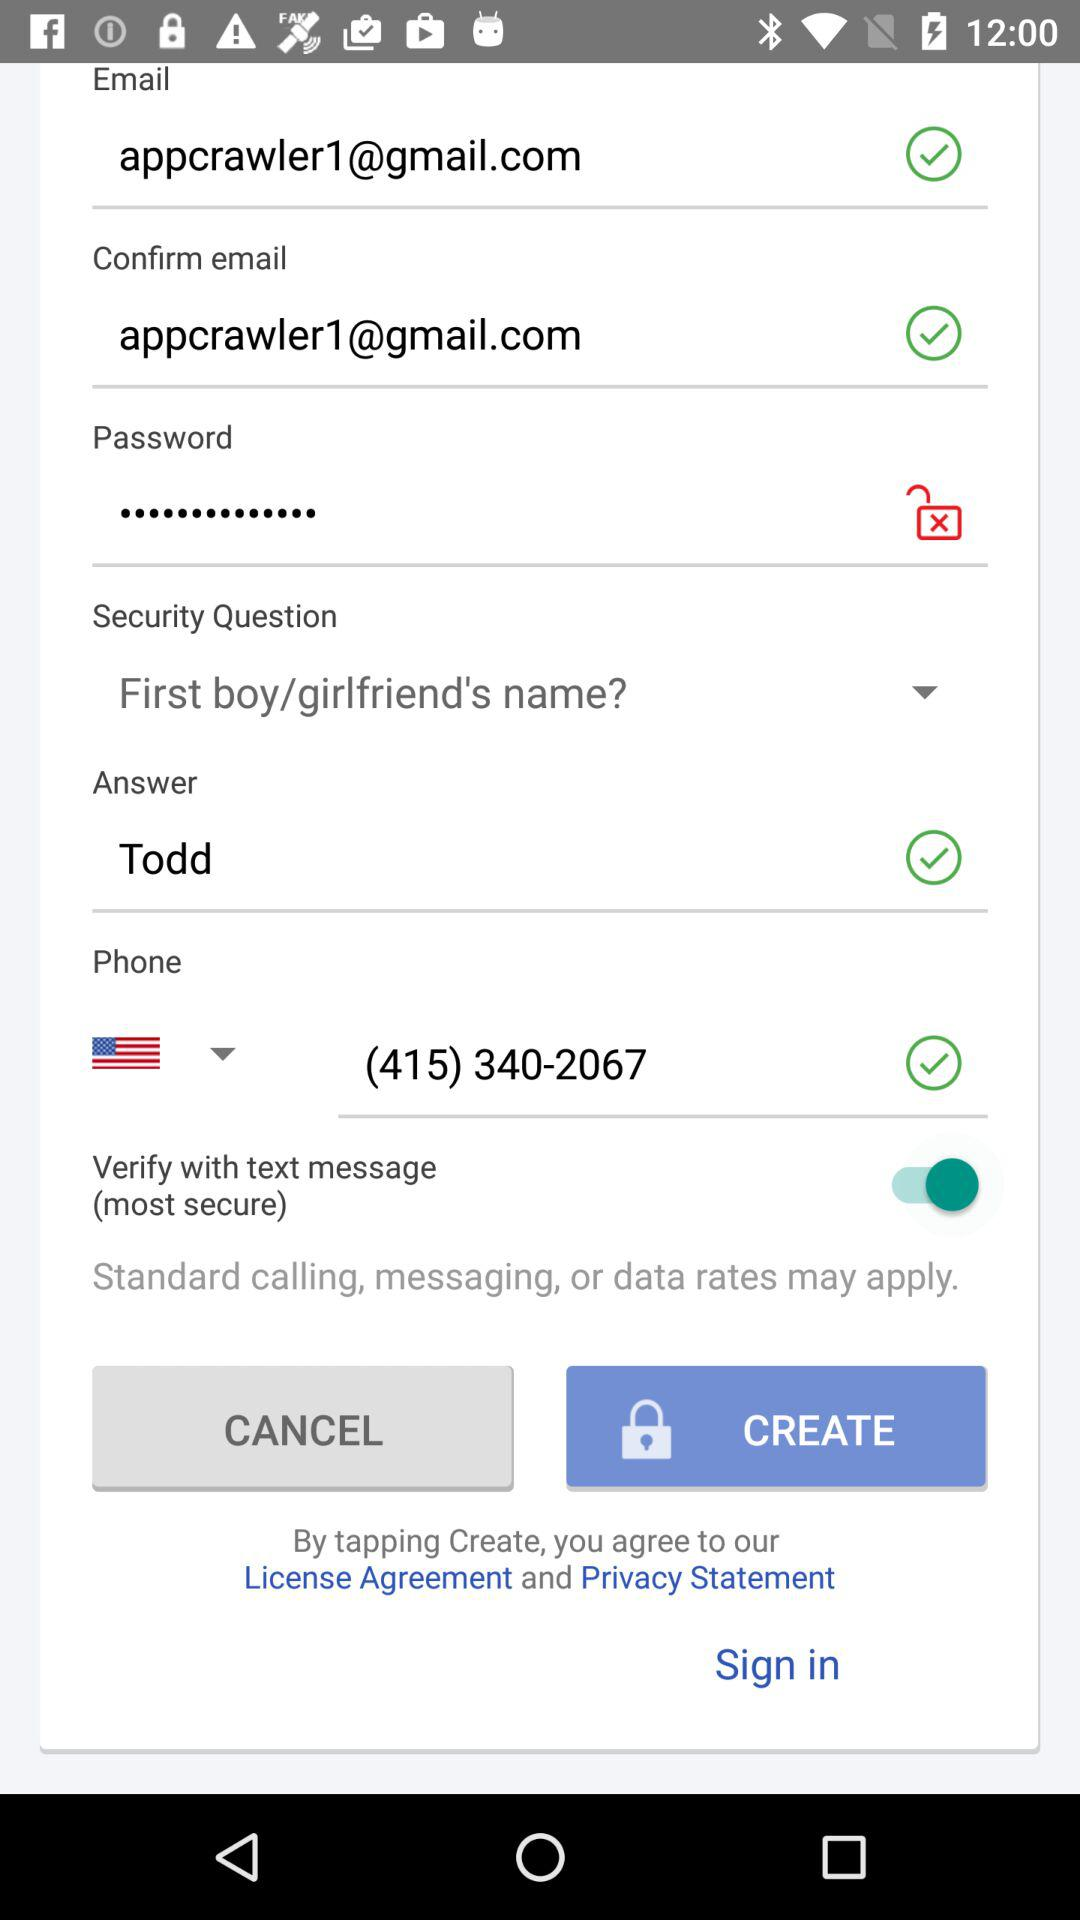What is the answer? The answer is "Todd". 